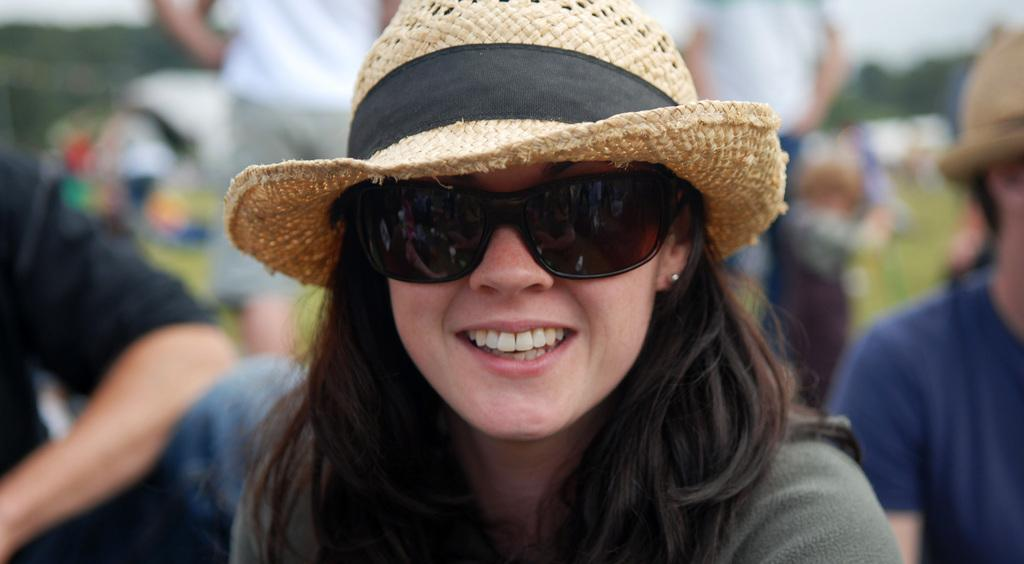Who is the main subject in the image? There is a lady in the image. What is the lady wearing on her face? The lady is wearing goggles. What type of headwear is the lady wearing? The lady is wearing a hat. Can you describe the background of the image? The background of the image is blurred. Are there any other people visible in the image? Yes, there are people in the background of the image. What type of prose is the lady reciting in the image? There is no indication in the image that the lady is reciting any prose. Can you see the lady's ear in the image? The image does not provide a clear view of the lady's ear, as it is not the focus of the image. 